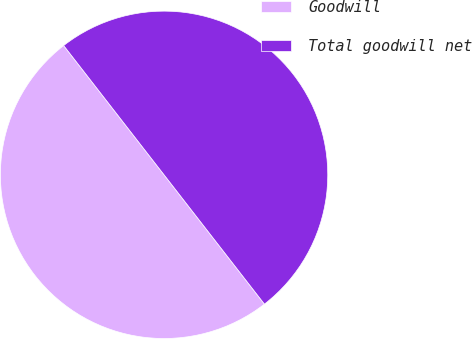<chart> <loc_0><loc_0><loc_500><loc_500><pie_chart><fcel>Goodwill<fcel>Total goodwill net<nl><fcel>50.0%<fcel>50.0%<nl></chart> 